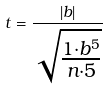Convert formula to latex. <formula><loc_0><loc_0><loc_500><loc_500>t = \frac { | b | } { \sqrt { \frac { 1 \cdot b ^ { 5 } } { n \cdot 5 } } }</formula> 